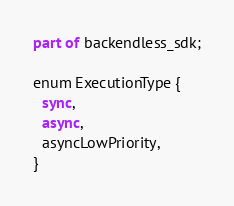<code> <loc_0><loc_0><loc_500><loc_500><_Dart_>part of backendless_sdk;

enum ExecutionType {
  sync,
  async,
  asyncLowPriority,
}
</code> 